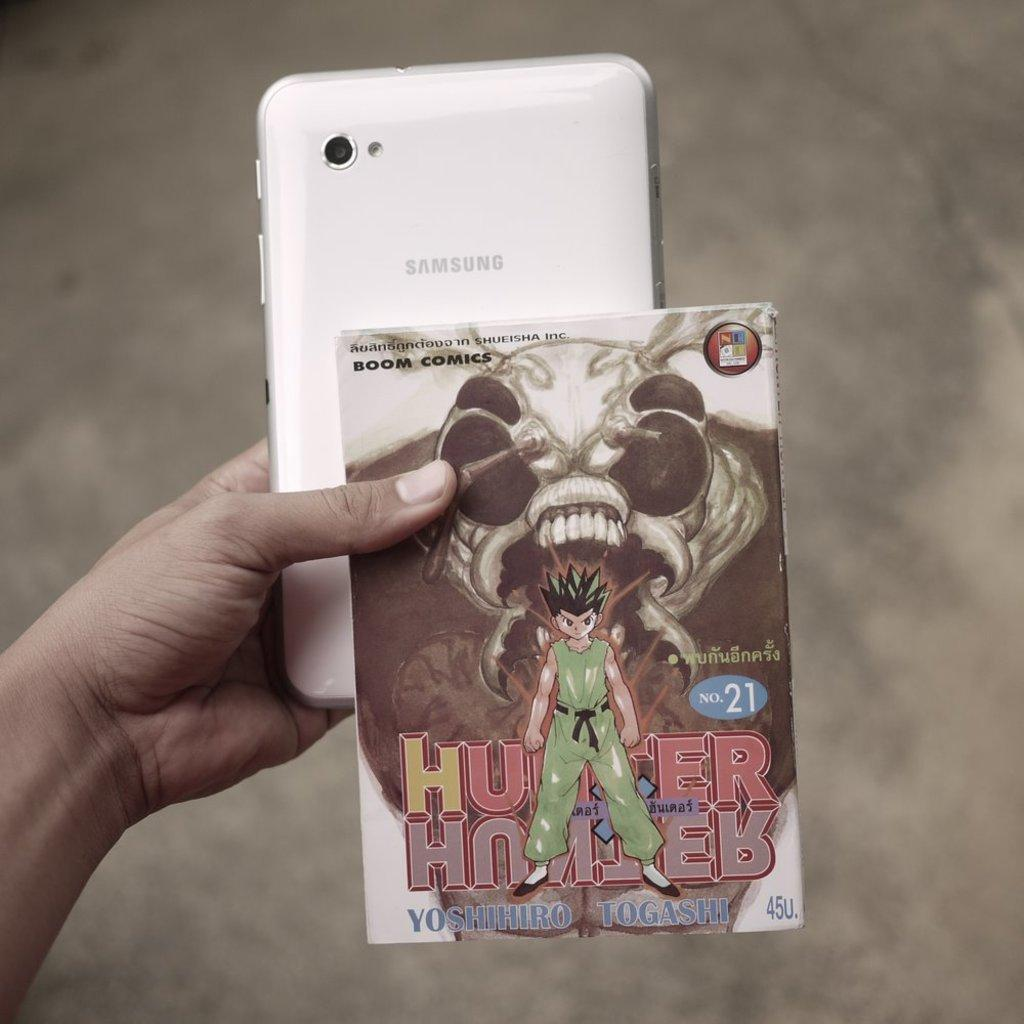What is the main subject of the image? There is a person in the image. What is the person holding in their hand? The person is holding a mobile phone and a card in their hand. How many pizzas can be seen floating in the ocean in the image? There are no pizzas or ocean present in the image; it features a person holding a mobile phone and a card. Is the person flying a kite in the image? There is no kite present in the image; the person is holding a mobile phone and a card. 